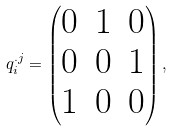<formula> <loc_0><loc_0><loc_500><loc_500>q _ { i } ^ { . j } = \begin{pmatrix} 0 & 1 & 0 \\ 0 & 0 & 1 \\ 1 & 0 & 0 \\ \end{pmatrix} ,</formula> 